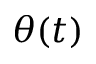<formula> <loc_0><loc_0><loc_500><loc_500>\theta ( t )</formula> 